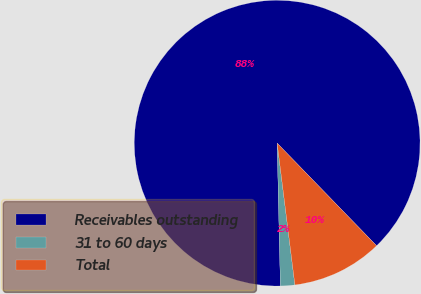Convert chart. <chart><loc_0><loc_0><loc_500><loc_500><pie_chart><fcel>Receivables outstanding<fcel>31 to 60 days<fcel>Total<nl><fcel>88.11%<fcel>1.62%<fcel>10.27%<nl></chart> 